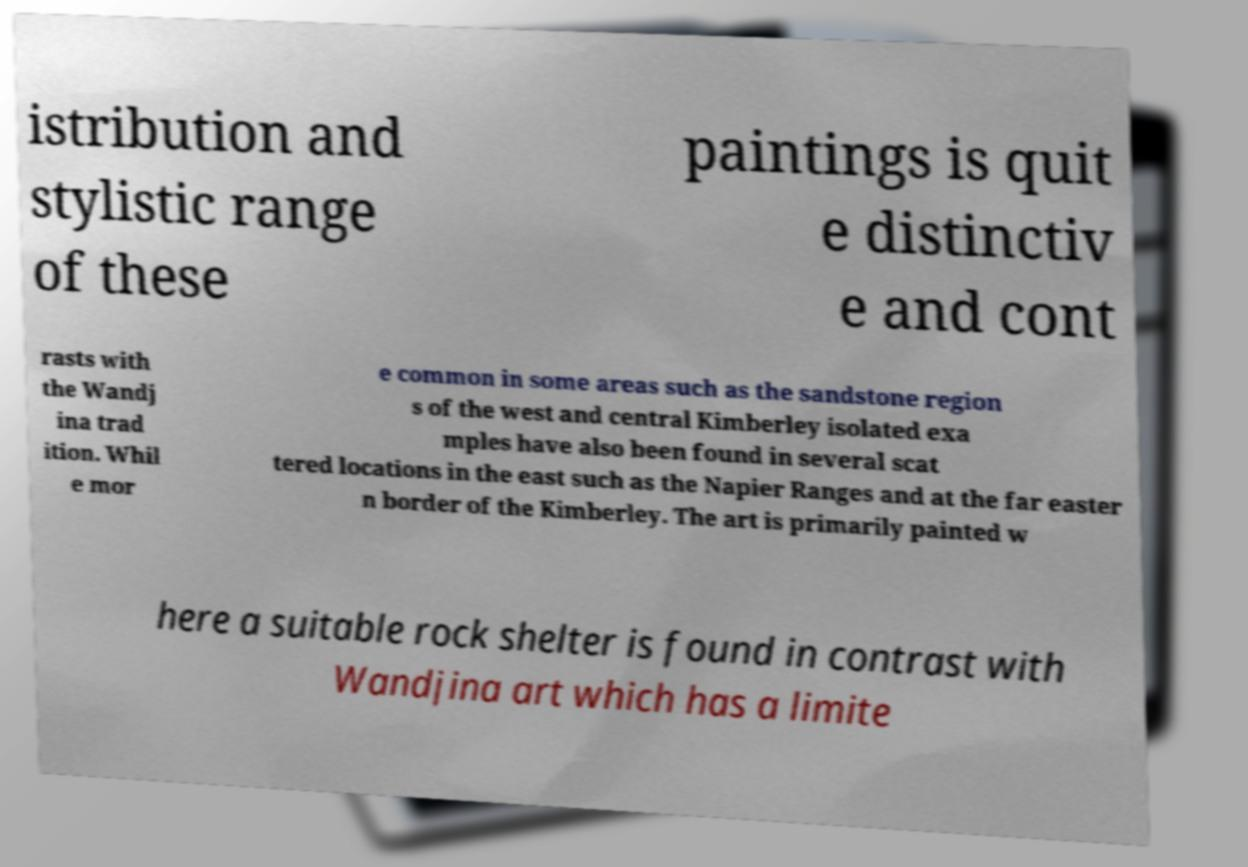Please read and relay the text visible in this image. What does it say? istribution and stylistic range of these paintings is quit e distinctiv e and cont rasts with the Wandj ina trad ition. Whil e mor e common in some areas such as the sandstone region s of the west and central Kimberley isolated exa mples have also been found in several scat tered locations in the east such as the Napier Ranges and at the far easter n border of the Kimberley. The art is primarily painted w here a suitable rock shelter is found in contrast with Wandjina art which has a limite 